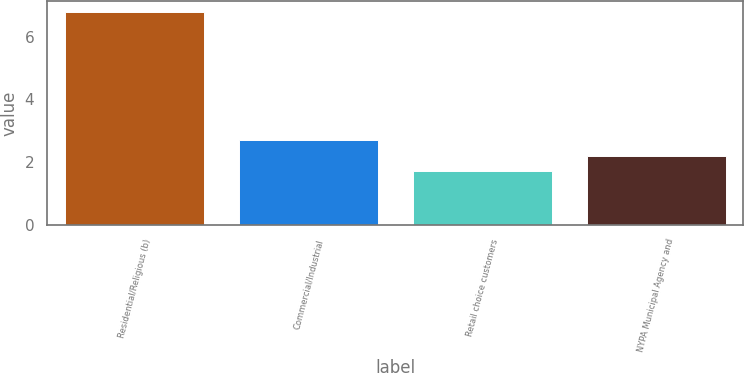Convert chart to OTSL. <chart><loc_0><loc_0><loc_500><loc_500><bar_chart><fcel>Residential/Religious (b)<fcel>Commercial/Industrial<fcel>Retail choice customers<fcel>NYPA Municipal Agency and<nl><fcel>6.8<fcel>2.72<fcel>1.7<fcel>2.21<nl></chart> 